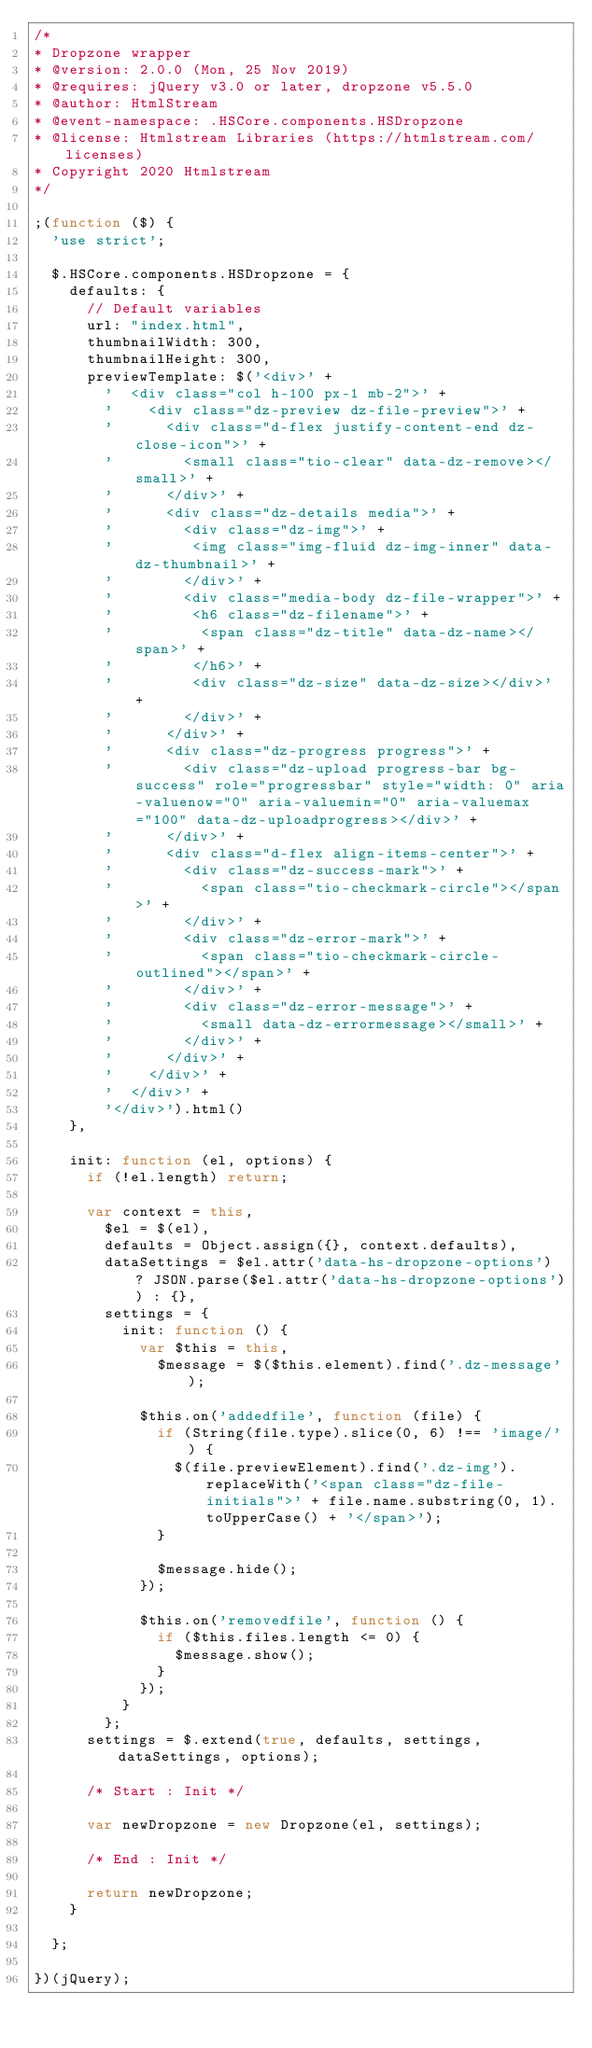Convert code to text. <code><loc_0><loc_0><loc_500><loc_500><_JavaScript_>/*
* Dropzone wrapper
* @version: 2.0.0 (Mon, 25 Nov 2019)
* @requires: jQuery v3.0 or later, dropzone v5.5.0
* @author: HtmlStream
* @event-namespace: .HSCore.components.HSDropzone
* @license: Htmlstream Libraries (https://htmlstream.com/licenses)
* Copyright 2020 Htmlstream
*/

;(function ($) {
	'use strict';

	$.HSCore.components.HSDropzone = {
		defaults: {
			// Default variables
			url: "index.html",
			thumbnailWidth: 300,
			thumbnailHeight: 300,
			previewTemplate: $('<div>' +
				'  <div class="col h-100 px-1 mb-2">' +
				'    <div class="dz-preview dz-file-preview">' +
				'      <div class="d-flex justify-content-end dz-close-icon">' +
				'        <small class="tio-clear" data-dz-remove></small>' +
				'      </div>' +
				'      <div class="dz-details media">' +
				'        <div class="dz-img">' +
				'         <img class="img-fluid dz-img-inner" data-dz-thumbnail>' +
				'        </div>' +
				'        <div class="media-body dz-file-wrapper">' +
				'         <h6 class="dz-filename">' +
				'          <span class="dz-title" data-dz-name></span>' +
				'         </h6>' +
				'         <div class="dz-size" data-dz-size></div>' +
				'        </div>' +
				'      </div>' +
				'      <div class="dz-progress progress">' +
				'        <div class="dz-upload progress-bar bg-success" role="progressbar" style="width: 0" aria-valuenow="0" aria-valuemin="0" aria-valuemax="100" data-dz-uploadprogress></div>' +
				'      </div>' +
				'      <div class="d-flex align-items-center">' +
				'        <div class="dz-success-mark">' +
				'          <span class="tio-checkmark-circle"></span>' +
				'        </div>' +
				'        <div class="dz-error-mark">' +
				'          <span class="tio-checkmark-circle-outlined"></span>' +
				'        </div>' +
				'        <div class="dz-error-message">' +
				'          <small data-dz-errormessage></small>' +
				'        </div>' +
				'      </div>' +
				'    </div>' +
				'  </div>' +
				'</div>').html()
		},

		init: function (el, options) {
			if (!el.length) return;

			var context = this,
				$el = $(el),
				defaults = Object.assign({}, context.defaults),
				dataSettings = $el.attr('data-hs-dropzone-options') ? JSON.parse($el.attr('data-hs-dropzone-options')) : {},
				settings = {
					init: function () {
						var $this = this,
							$message = $($this.element).find('.dz-message');

						$this.on('addedfile', function (file) {
							if (String(file.type).slice(0, 6) !== 'image/') {
								$(file.previewElement).find('.dz-img').replaceWith('<span class="dz-file-initials">' + file.name.substring(0, 1).toUpperCase() + '</span>');
							}

							$message.hide();
						});

						$this.on('removedfile', function () {
							if ($this.files.length <= 0) {
								$message.show();
							}
						});
					}
				};
			settings = $.extend(true, defaults, settings, dataSettings, options);

			/* Start : Init */

			var newDropzone = new Dropzone(el, settings);

			/* End : Init */

			return newDropzone;
		}

	};

})(jQuery);
</code> 